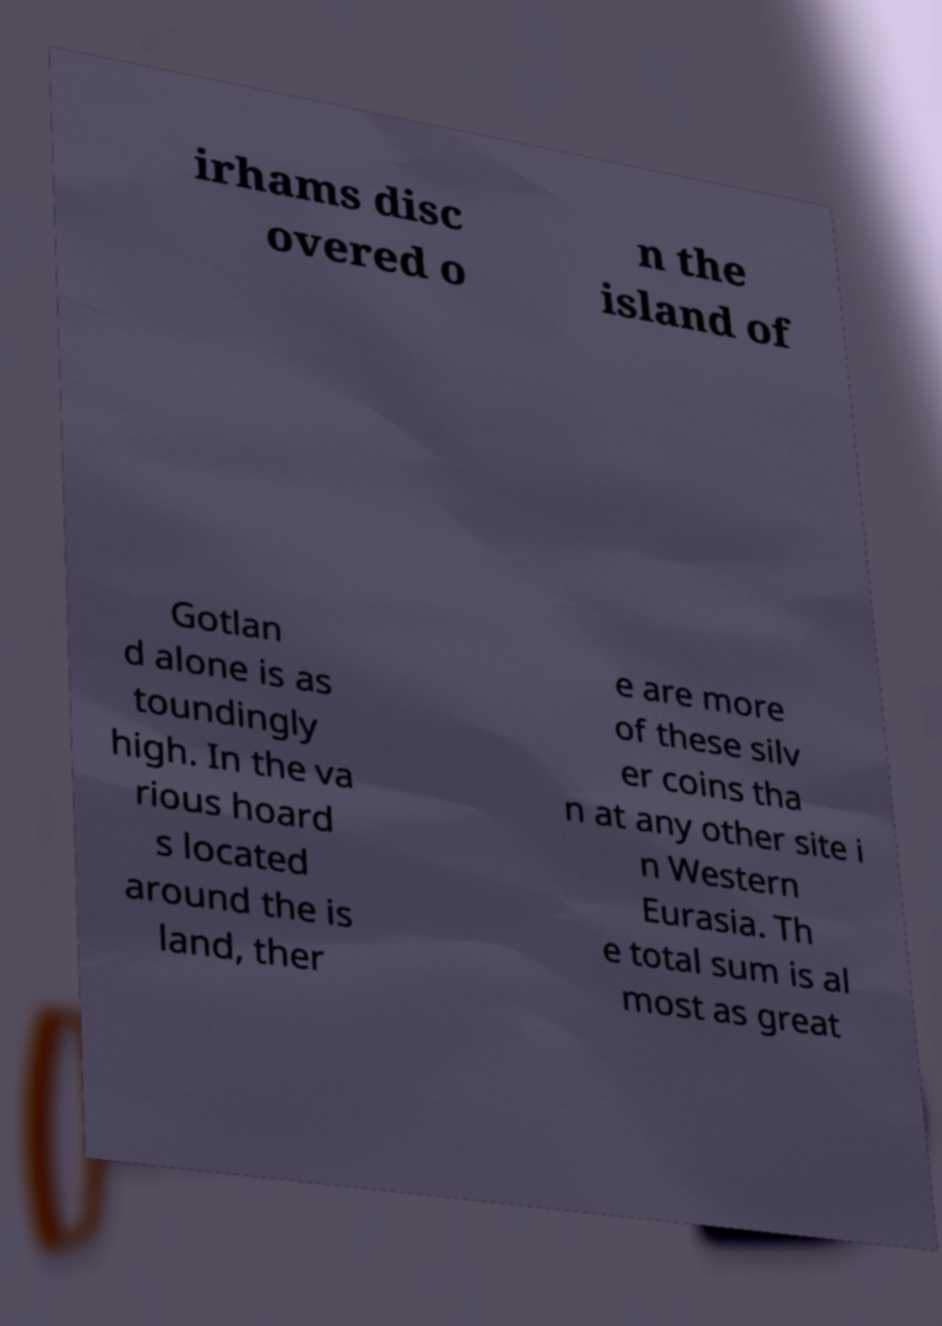Can you accurately transcribe the text from the provided image for me? irhams disc overed o n the island of Gotlan d alone is as toundingly high. In the va rious hoard s located around the is land, ther e are more of these silv er coins tha n at any other site i n Western Eurasia. Th e total sum is al most as great 